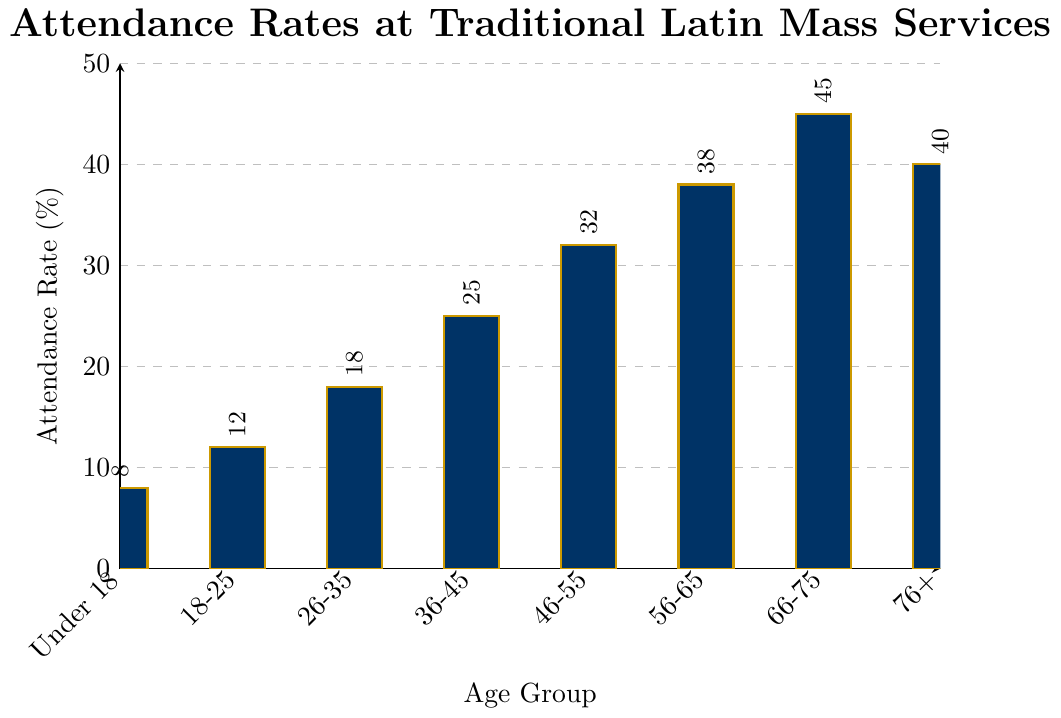Which age group has the highest attendance rate? To find the age group with the highest attendance rate, look at the height of the bars. The tallest bar corresponds to the 66-75 age group with an attendance rate of 45%.
Answer: 66-75 What is the difference in attendance rates between the 46-55 and 76+ age groups? The attendance rate for the 46-55 age group is 32%, and for the 76+ age group, it is 40%. The difference is calculated as 40% - 32% = 8%.
Answer: 8% Which age group has the lowest attendance rate? The bar with the shortest height corresponds to the Under 18 age group with an attendance rate of 8%.
Answer: Under 18 What is the average attendance rate for age groups 18-25, 26-35, and 36-45? To find the average, sum the attendance rates for the groups: 12% (18-25) + 18% (26-35) + 25% (36-45) = 55%. Then, divide by the number of groups, which is 3. The average is 55/3 ≈ 18.33%.
Answer: 18.33% Is the attendance rate for the 56-65 age group greater than the average rate of all groups? Average attendance rate for all groups: (8 + 12 + 18 + 25 + 32 + 38 + 45 + 40) / 8 = 26%. The attendance rate for 56-65 age group is 38%, which is greater than 26%.
Answer: Yes What is the total attendance rate for the age groups above 55 years? Sum the attendance rates for age groups 56-65, 66-75, and 76+: 38% + 45% + 40% = 123%.
Answer: 123% Which two adjacent age groups have the smallest difference in attendance rates? Compare the differences between adjacent groups: (12% - 8%), (18% - 12%), (25% - 18%), (32% - 25%), (38% - 32%), (45% - 38%), (40% - 45%). The smallest difference is between 66-75 and 76+ with a difference of 5%.
Answer: 66-75 and 76+ Is the attendance rate of the 26-35 age group less than that of the 46-55 age group? The attendance rate for the 26-35 age group is 18%, and for the 46-55 age group, it is 32%. Since 18% is less than 32%, the answer is yes.
Answer: Yes What is the median attendance rate across all age groups? Arrange the attendance rates in ascending order: 8%, 12%, 18%, 25%, 32%, 38%, 40%, 45%. The median is the average of the 4th and 5th values: (25% + 32%) / 2 = 28.5%.
Answer: 28.5% What is the rate increase in attendance from the Under 18 group to the 26-35 group? The attendance rate for the Under 18 group is 8%, and for the 26-35 group, it is 18%. The increase is 18% - 8% = 10%.
Answer: 10% 